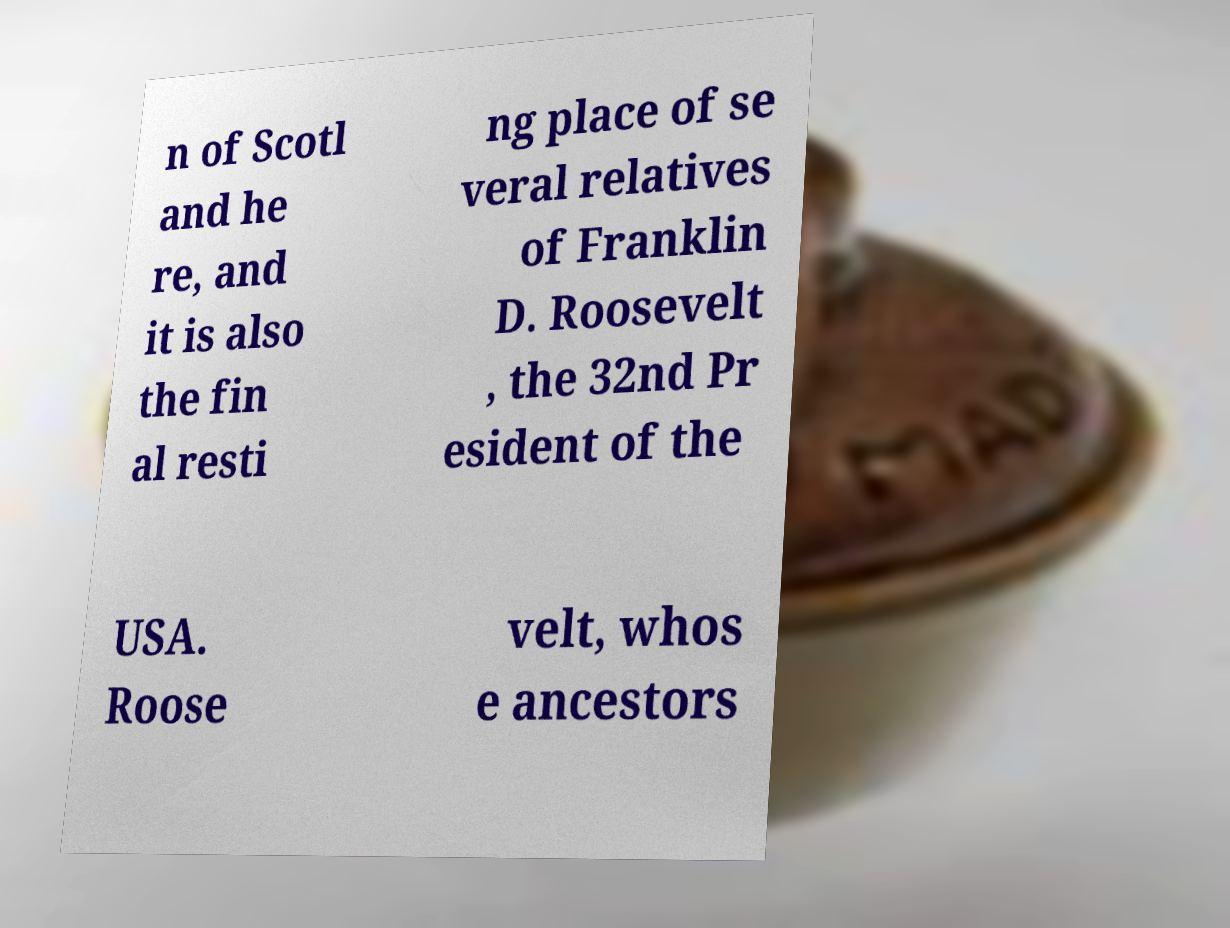Can you accurately transcribe the text from the provided image for me? n of Scotl and he re, and it is also the fin al resti ng place of se veral relatives of Franklin D. Roosevelt , the 32nd Pr esident of the USA. Roose velt, whos e ancestors 